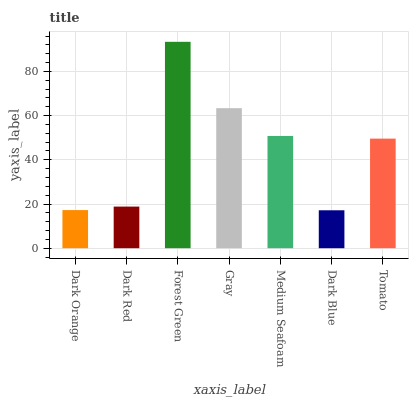Is Dark Blue the minimum?
Answer yes or no. Yes. Is Forest Green the maximum?
Answer yes or no. Yes. Is Dark Red the minimum?
Answer yes or no. No. Is Dark Red the maximum?
Answer yes or no. No. Is Dark Red greater than Dark Orange?
Answer yes or no. Yes. Is Dark Orange less than Dark Red?
Answer yes or no. Yes. Is Dark Orange greater than Dark Red?
Answer yes or no. No. Is Dark Red less than Dark Orange?
Answer yes or no. No. Is Tomato the high median?
Answer yes or no. Yes. Is Tomato the low median?
Answer yes or no. Yes. Is Dark Blue the high median?
Answer yes or no. No. Is Medium Seafoam the low median?
Answer yes or no. No. 